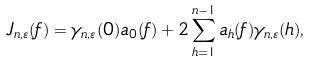<formula> <loc_0><loc_0><loc_500><loc_500>J _ { n , \varepsilon } ( f ) = \gamma _ { n , \varepsilon } ( 0 ) a _ { 0 } ( f ) + 2 \sum _ { h = 1 } ^ { n - 1 } a _ { h } ( f ) \gamma _ { n , \varepsilon } ( h ) ,</formula> 